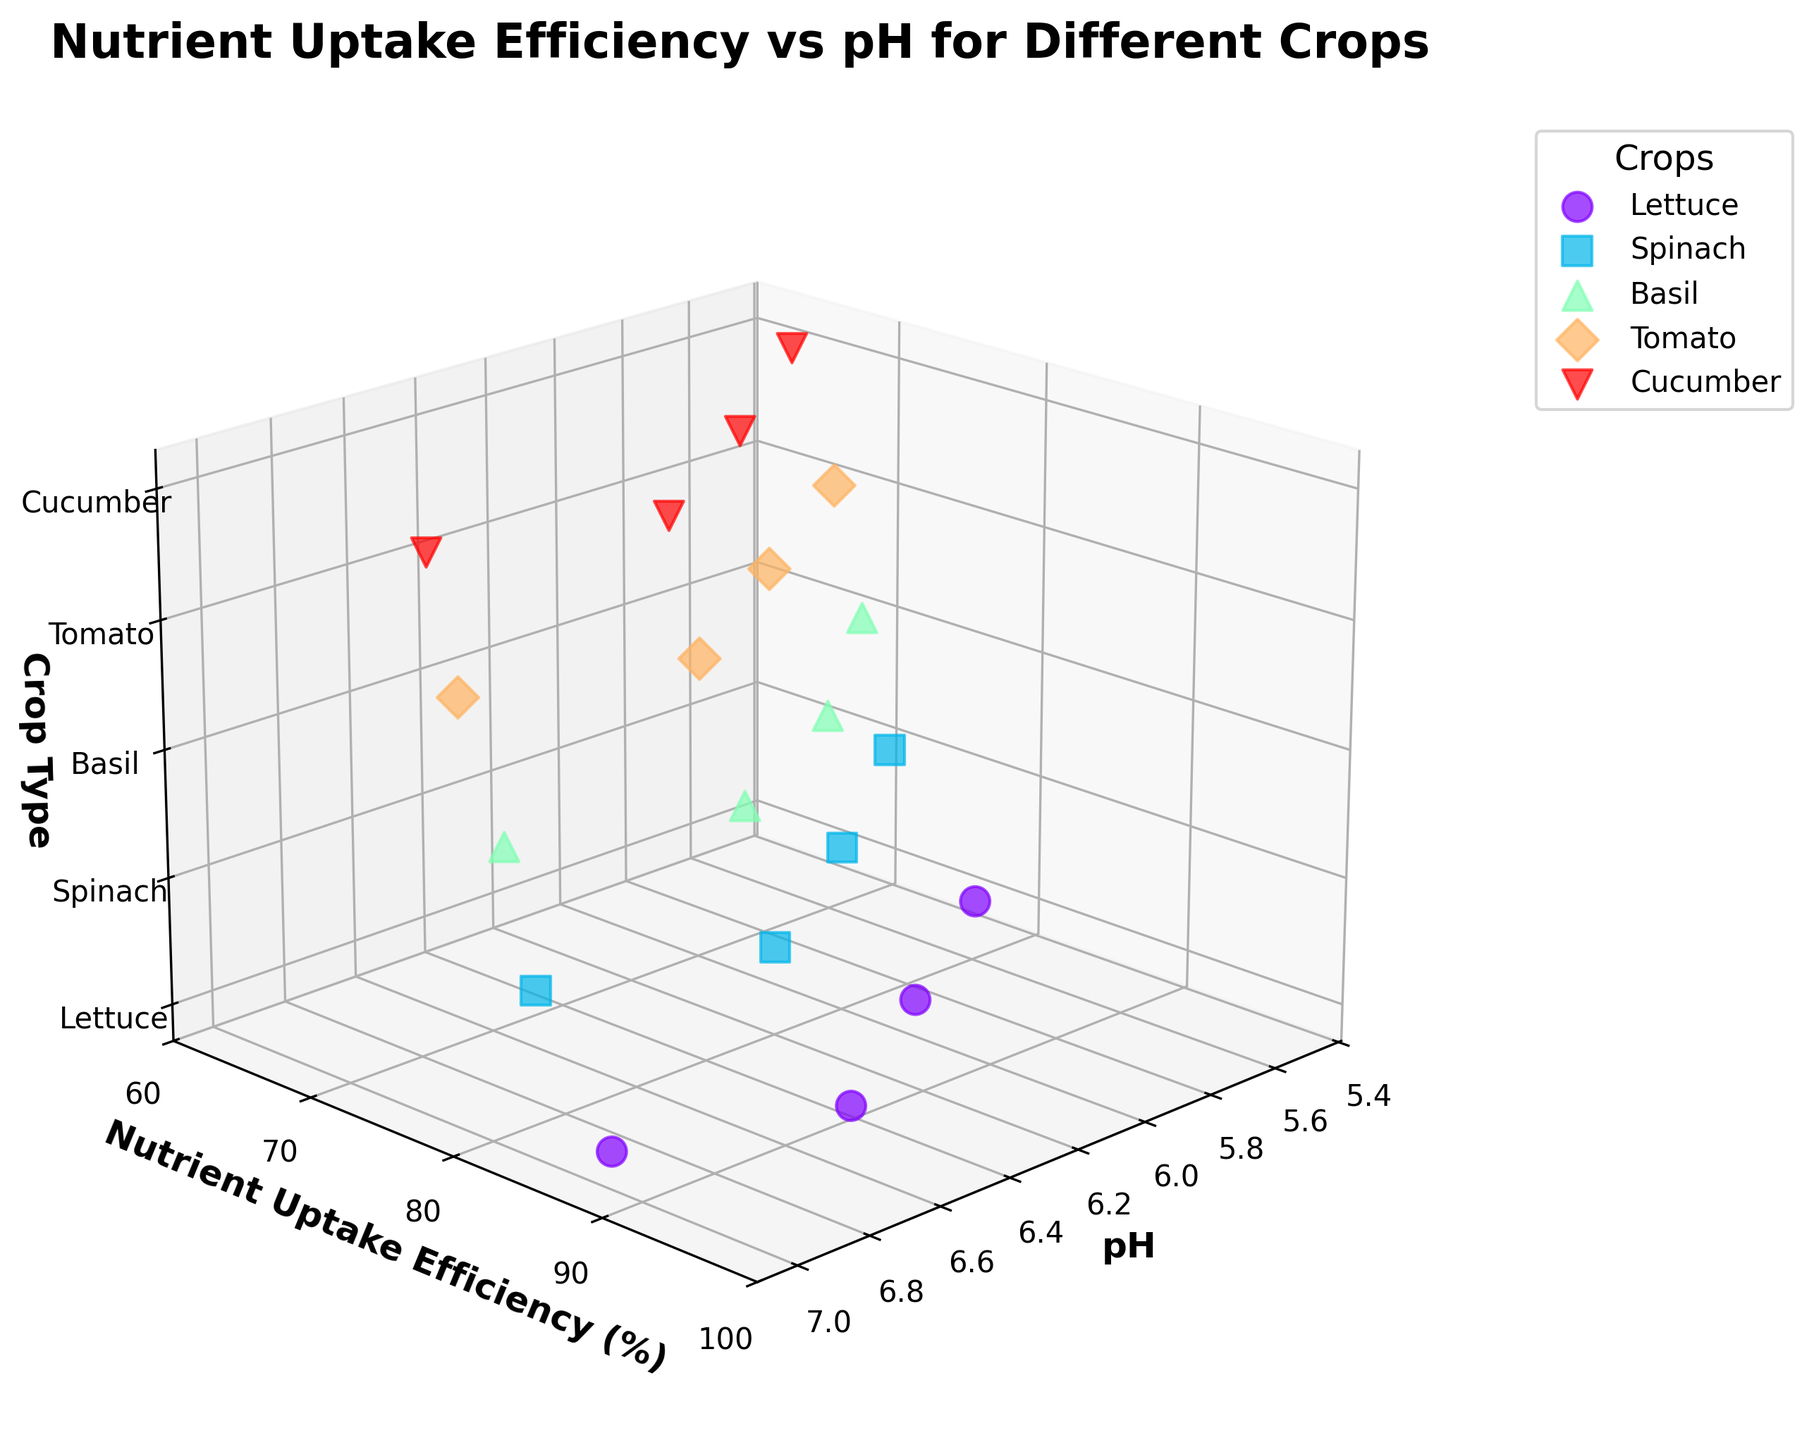What is the title of the plot? The title can be identified easily at the top of the plot.
Answer: Nutrient Uptake Efficiency vs pH for Different Crops Which axis represents the pH levels? The labels of the axes indicate what each axis represents; the x-axis is labeled 'pH'.
Answer: x-axis What is the pH level at which Basil shows maximum nutrient uptake efficiency? By observing the data points for Basil, we can notice that the highest Nutrient Uptake Efficiency occurs at pH 6.5.
Answer: 6.5 How many unique crops are represented in the figure? The z-axis is labeled with different crop types, and there appear to be 5 unique crops.
Answer: 5 What is the range of the nutrient uptake efficiency values? The y-axis represents Nutrient Uptake Efficiency, which varies from 65 (Cucumber at pH 5.5) to 92 (Lettuce at pH 6.5).
Answer: 65 to 92 Which crop shows the least nutrient uptake efficiency at pH 7.0? By observing the nutrient uptake efficiency values for all crops at pH 7.0, we can see that Cucumber has the lowest at 76.
Answer: Cucumber At pH 6.0, which crop has the highest nutrient uptake efficiency and what is the value? By looking at the data points along pH 6.0, the crop with the highest nutrient uptake efficiency is Lettuce with a value of 85.
Answer: Lettuce, 85 How does the nutrient uptake efficiency of Tomato change from pH 5.5 to pH 7.0? By following the data points for Tomato, the efficiency increases from 68 (pH 5.5) to 75 (pH 6.0), then to 82 (pH 6.5) and decreases to 78 (pH 7.0).
Answer: Increases to 82 at pH 6.5, then decreases to 78 Compare the nutrient uptake efficiency of Spinach and Basil at pH 6.0. Which is higher and by how much? By observing the values at pH 6.0, Spinach has 80, while Basil has 79. The difference is 80 - 79 = 1.
Answer: Spinach, by 1 